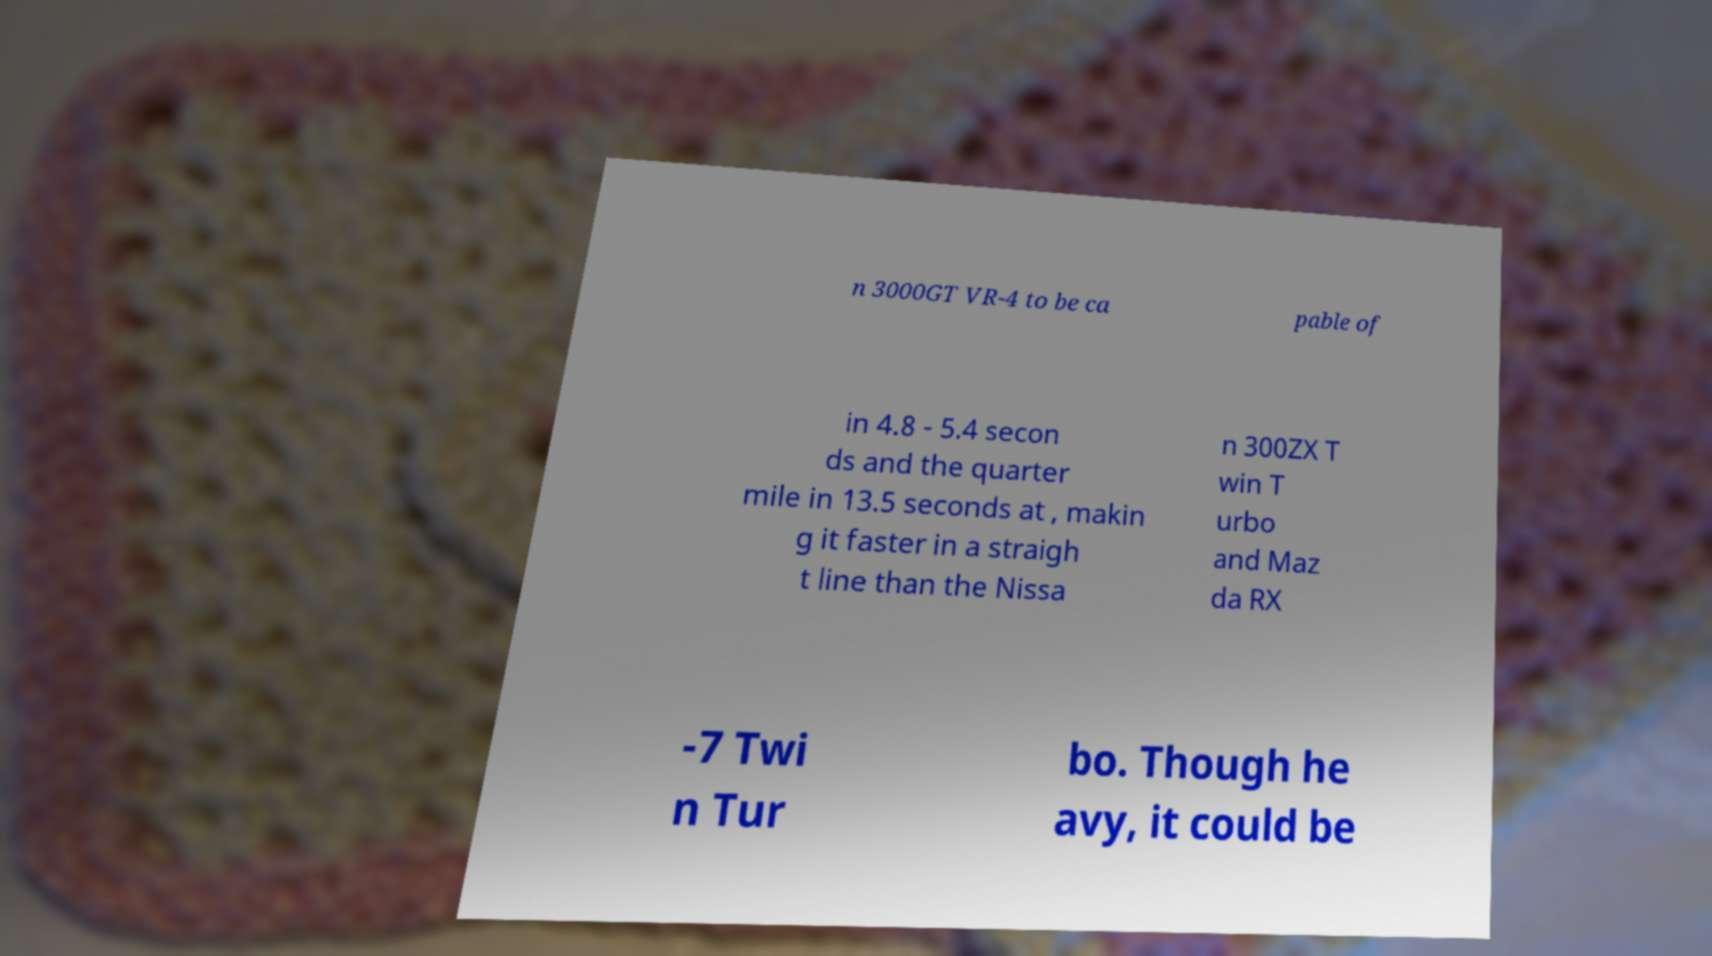Could you assist in decoding the text presented in this image and type it out clearly? n 3000GT VR-4 to be ca pable of in 4.8 - 5.4 secon ds and the quarter mile in 13.5 seconds at , makin g it faster in a straigh t line than the Nissa n 300ZX T win T urbo and Maz da RX -7 Twi n Tur bo. Though he avy, it could be 